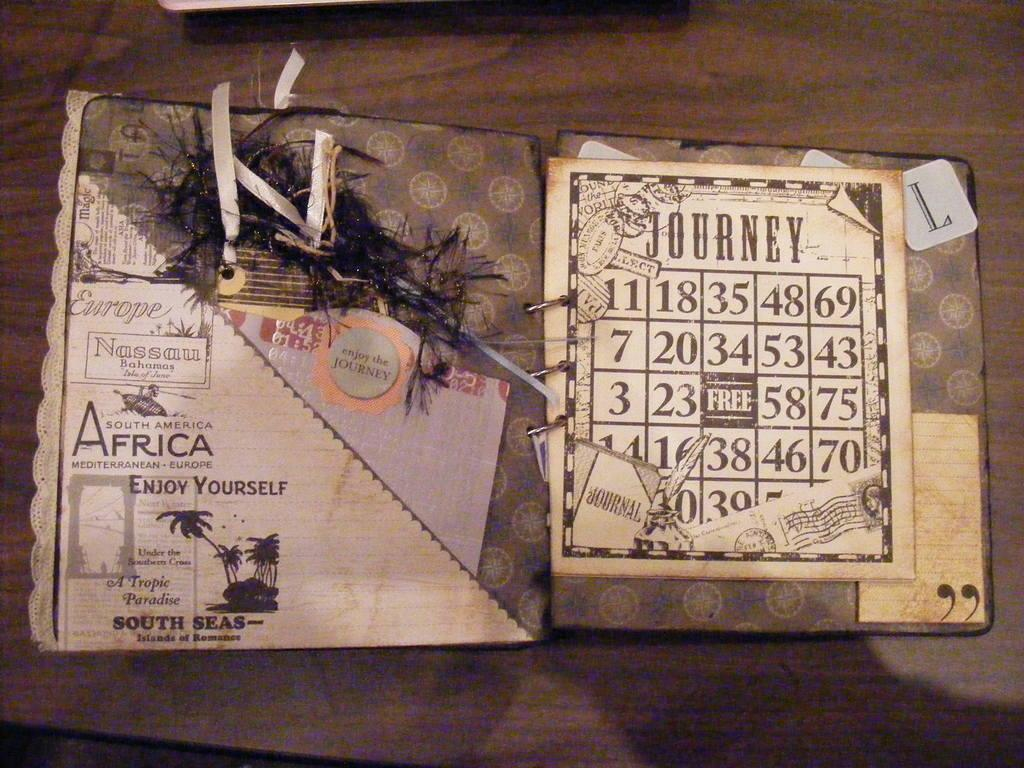Provide a one-sentence caption for the provided image. A postcard from Africa with a Journey bingo card on the front. 